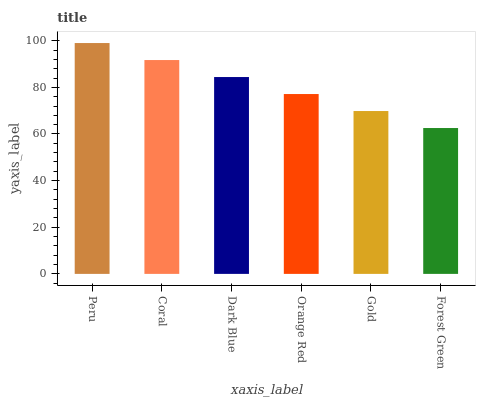Is Coral the minimum?
Answer yes or no. No. Is Coral the maximum?
Answer yes or no. No. Is Peru greater than Coral?
Answer yes or no. Yes. Is Coral less than Peru?
Answer yes or no. Yes. Is Coral greater than Peru?
Answer yes or no. No. Is Peru less than Coral?
Answer yes or no. No. Is Dark Blue the high median?
Answer yes or no. Yes. Is Orange Red the low median?
Answer yes or no. Yes. Is Peru the high median?
Answer yes or no. No. Is Dark Blue the low median?
Answer yes or no. No. 